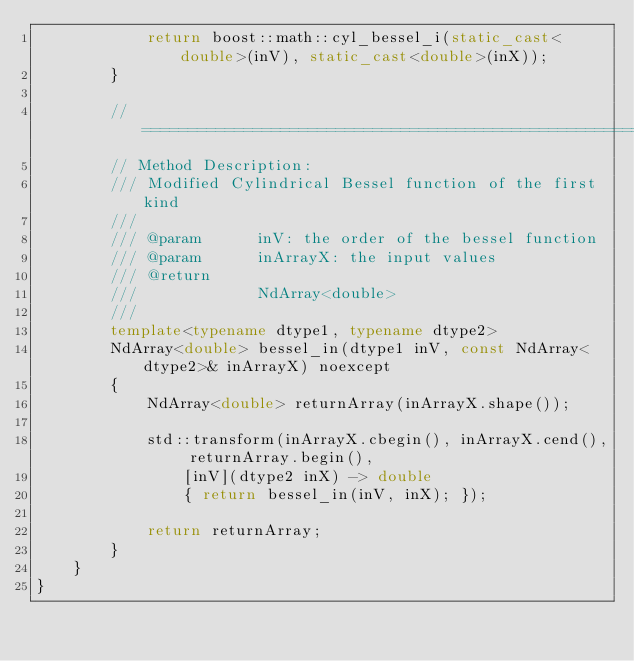Convert code to text. <code><loc_0><loc_0><loc_500><loc_500><_C++_>            return boost::math::cyl_bessel_i(static_cast<double>(inV), static_cast<double>(inX));
        }

        //============================================================================
        // Method Description:
        ///	Modified Cylindrical Bessel function of the first kind
        ///
        /// @param      inV: the order of the bessel function
        /// @param      inArrayX: the input values
        /// @return
        ///				NdArray<double>
        ///
        template<typename dtype1, typename dtype2>
        NdArray<double> bessel_in(dtype1 inV, const NdArray<dtype2>& inArrayX) noexcept
        {
            NdArray<double> returnArray(inArrayX.shape());

            std::transform(inArrayX.cbegin(), inArrayX.cend(), returnArray.begin(),
                [inV](dtype2 inX) -> double
                { return bessel_in(inV, inX); });

            return returnArray;
        }
    }
}
</code> 